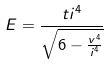Convert formula to latex. <formula><loc_0><loc_0><loc_500><loc_500>E = \frac { t i ^ { 4 } } { \sqrt { 6 - \frac { v ^ { 4 } } { i ^ { 4 } } } }</formula> 